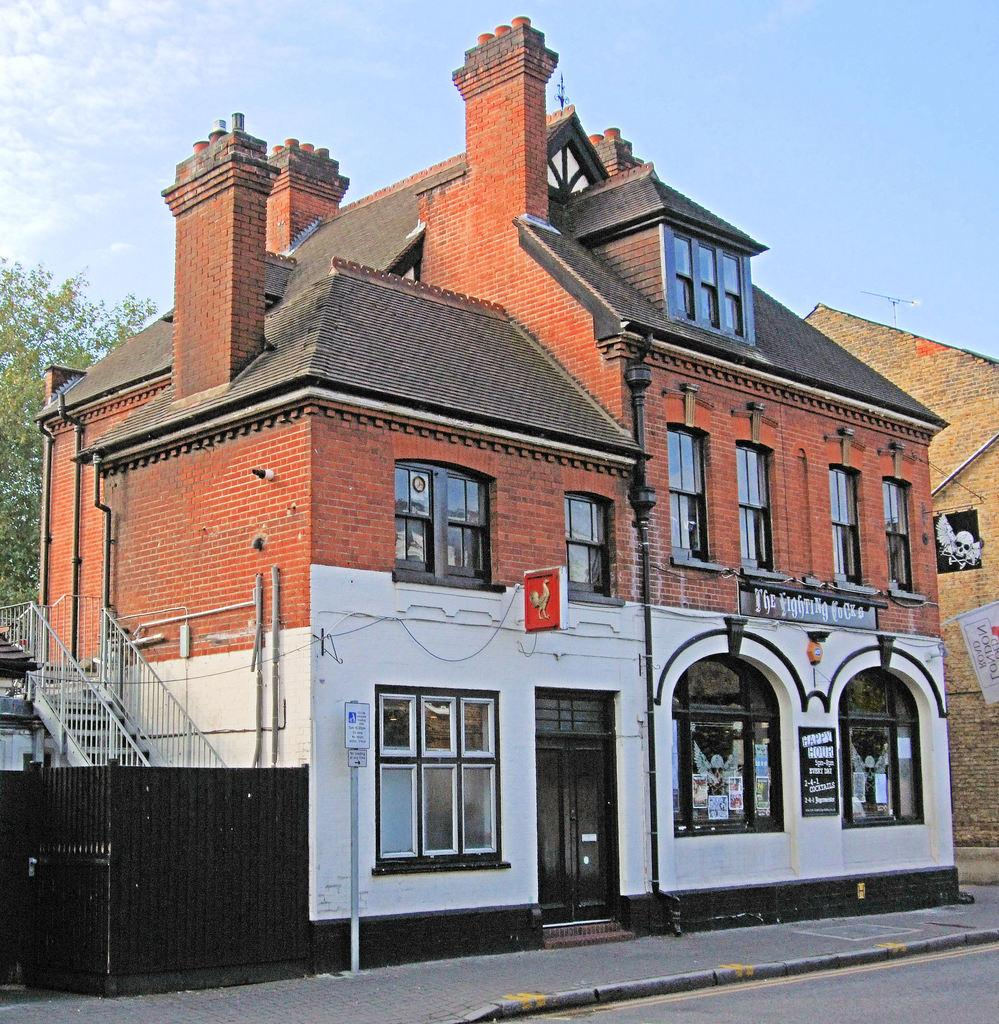What type of structure is present in the image? There is a house in the image. What features can be observed on the house? The house has a roof, windows, a board, and stairs. What else is present in the image besides the house? There is a fence and a tree visible in the image. What can be seen in the sky in the image? The sky is visible in the image, and it appears to be cloudy. Can you tell me how many pears are hanging from the cable in the image? There is no cable or pear present in the image. What type of lizards can be seen climbing on the tree in the image? There are no lizards visible in the image; only the tree is present. 